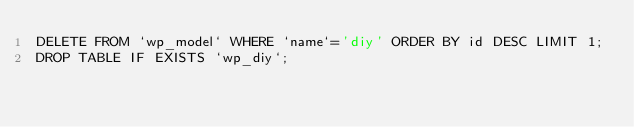<code> <loc_0><loc_0><loc_500><loc_500><_SQL_>DELETE FROM `wp_model` WHERE `name`='diy' ORDER BY id DESC LIMIT 1;
DROP TABLE IF EXISTS `wp_diy`;</code> 